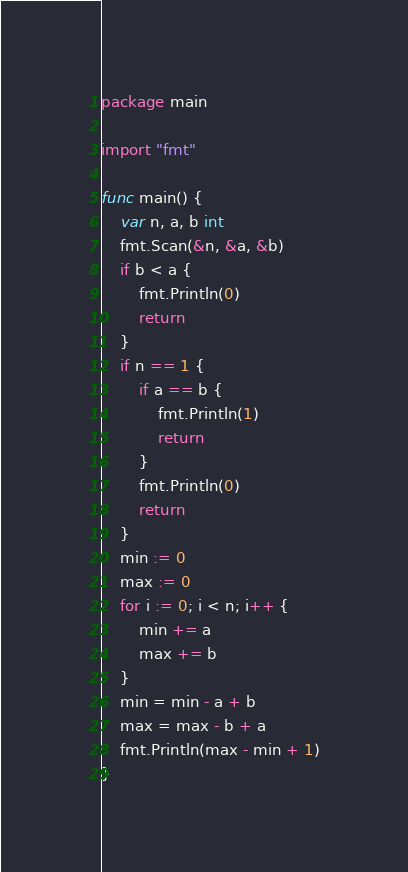<code> <loc_0><loc_0><loc_500><loc_500><_Go_>package main

import "fmt"

func main() {
	var n, a, b int
	fmt.Scan(&n, &a, &b)
	if b < a {
		fmt.Println(0)
		return
	}
	if n == 1 {
		if a == b {
			fmt.Println(1)
			return
		}
		fmt.Println(0)
		return
	}
	min := 0
	max := 0
	for i := 0; i < n; i++ {
		min += a
		max += b
	}
	min = min - a + b
	max = max - b + a
	fmt.Println(max - min + 1)
}
</code> 